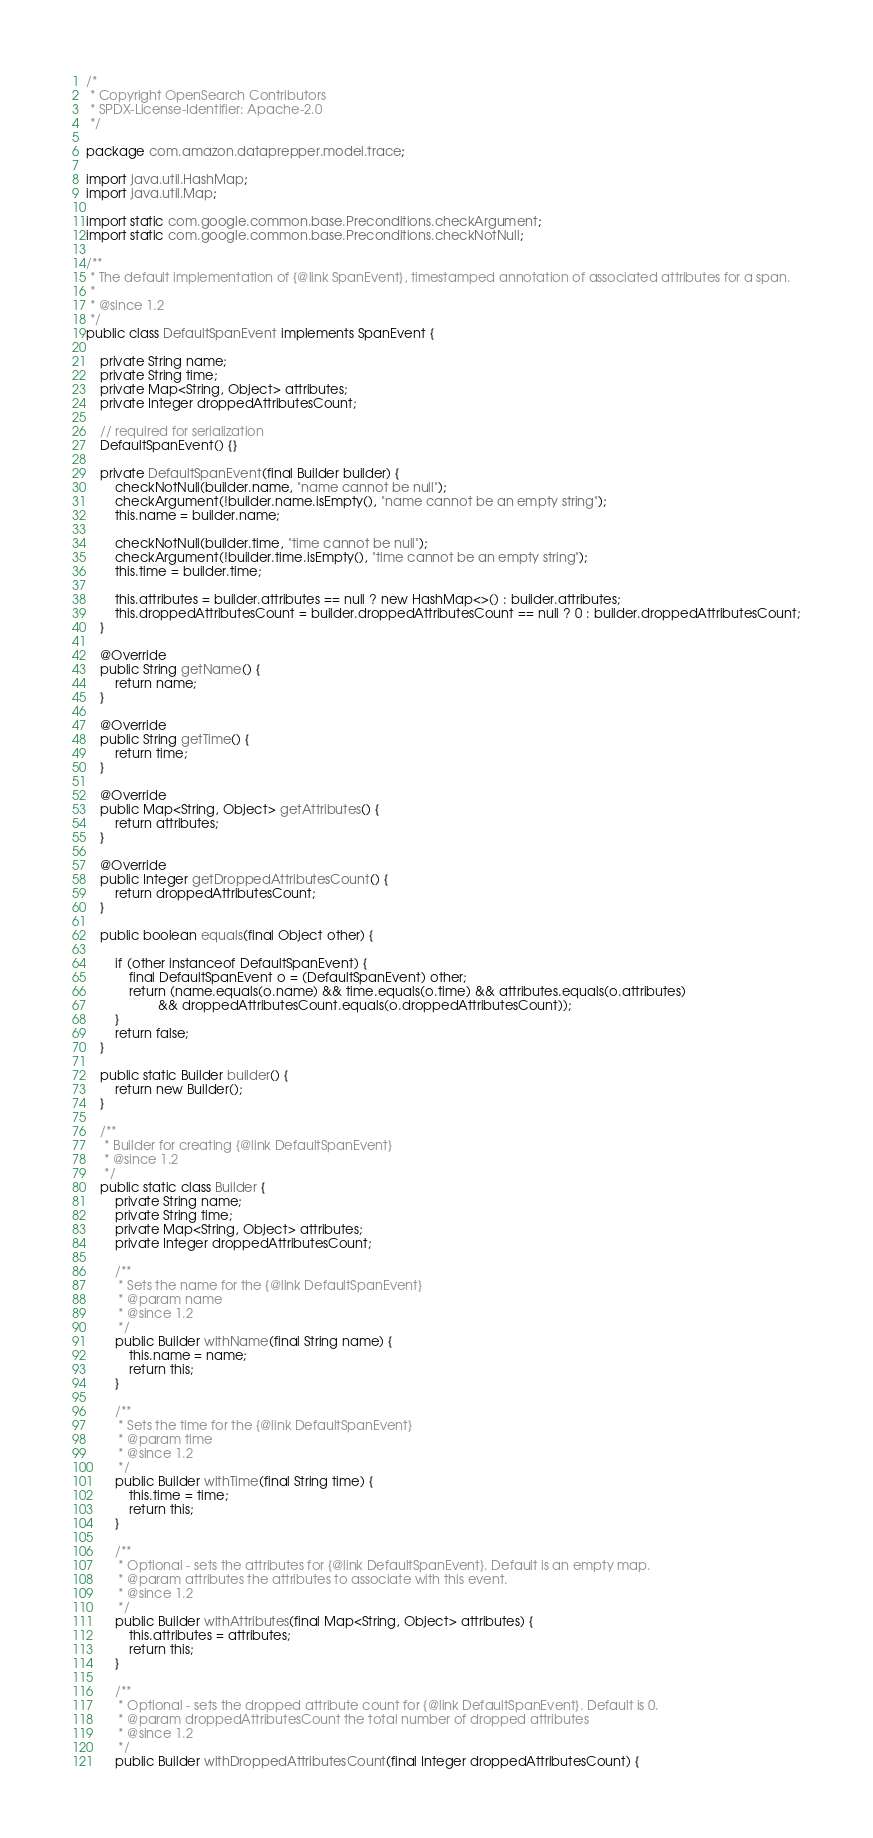<code> <loc_0><loc_0><loc_500><loc_500><_Java_>/*
 * Copyright OpenSearch Contributors
 * SPDX-License-Identifier: Apache-2.0
 */

package com.amazon.dataprepper.model.trace;

import java.util.HashMap;
import java.util.Map;

import static com.google.common.base.Preconditions.checkArgument;
import static com.google.common.base.Preconditions.checkNotNull;

/**
 * The default implementation of {@link SpanEvent}, timestamped annotation of associated attributes for a span.
 *
 * @since 1.2
 */
public class DefaultSpanEvent implements SpanEvent {

    private String name;
    private String time;
    private Map<String, Object> attributes;
    private Integer droppedAttributesCount;

    // required for serialization
    DefaultSpanEvent() {}

    private DefaultSpanEvent(final Builder builder) {
        checkNotNull(builder.name, "name cannot be null");
        checkArgument(!builder.name.isEmpty(), "name cannot be an empty string");
        this.name = builder.name;

        checkNotNull(builder.time, "time cannot be null");
        checkArgument(!builder.time.isEmpty(), "time cannot be an empty string");
        this.time = builder.time;

        this.attributes = builder.attributes == null ? new HashMap<>() : builder.attributes;
        this.droppedAttributesCount = builder.droppedAttributesCount == null ? 0 : builder.droppedAttributesCount;
    }

    @Override
    public String getName() {
        return name;
    }

    @Override
    public String getTime() {
        return time;
    }

    @Override
    public Map<String, Object> getAttributes() {
        return attributes;
    }

    @Override
    public Integer getDroppedAttributesCount() {
        return droppedAttributesCount;
    }

    public boolean equals(final Object other) {

        if (other instanceof DefaultSpanEvent) {
            final DefaultSpanEvent o = (DefaultSpanEvent) other;
            return (name.equals(o.name) && time.equals(o.time) && attributes.equals(o.attributes)
                    && droppedAttributesCount.equals(o.droppedAttributesCount));
        }
        return false;
    }

    public static Builder builder() {
        return new Builder();
    }

    /**
     * Builder for creating {@link DefaultSpanEvent}
     * @since 1.2
     */
    public static class Builder {
        private String name;
        private String time;
        private Map<String, Object> attributes;
        private Integer droppedAttributesCount;

        /**
         * Sets the name for the {@link DefaultSpanEvent}
         * @param name
         * @since 1.2
         */
        public Builder withName(final String name) {
            this.name = name;
            return this;
        }

        /**
         * Sets the time for the {@link DefaultSpanEvent}
         * @param time
         * @since 1.2
         */
        public Builder withTime(final String time) {
            this.time = time;
            return this;
        }

        /**
         * Optional - sets the attributes for {@link DefaultSpanEvent}. Default is an empty map.
         * @param attributes the attributes to associate with this event.
         * @since 1.2
         */
        public Builder withAttributes(final Map<String, Object> attributes) {
            this.attributes = attributes;
            return this;
        }

        /**
         * Optional - sets the dropped attribute count for {@link DefaultSpanEvent}. Default is 0.
         * @param droppedAttributesCount the total number of dropped attributes
         * @since 1.2
         */
        public Builder withDroppedAttributesCount(final Integer droppedAttributesCount) {</code> 